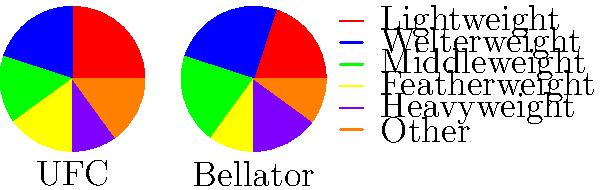As an MMA enthusiast with screenwriting experience, analyze the pie charts representing weight class distributions in UFC and Bellator. Which weight class shows the most significant difference in representation between the two organizations, and how might this impact storylines in an MMA-themed screenplay? To answer this question, we need to compare the weight class distributions between UFC and Bellator:

1. Lightweight:
   UFC: 25%, Bellator: 20%
   Difference: 5%

2. Welterweight:
   UFC: 20%, Bellator: 25%
   Difference: 5%

3. Middleweight:
   UFC: 15%, Bellator: 20%
   Difference: 5%

4. Featherweight:
   UFC: 15%, Bellator: 10%
   Difference: 5%

5. Heavyweight:
   UFC: 10%, Bellator: 15%
   Difference: 5%

6. Other:
   UFC: 15%, Bellator: 10%
   Difference: 5%

The most significant difference is a tie between all weight classes, each showing a 5% difference between UFC and Bellator.

For screenplay impact, consider:

1. Welterweight has the highest representation in Bellator (25%) vs. UFC (20%). This could lead to storylines about welterweight fighters choosing Bellator for more opportunities.

2. Lightweight has the highest representation in UFC (25%) vs. Bellator (20%). This might create narratives about lightweight fighters aspiring to compete in the UFC.

3. The "Other" category shows more diversity in UFC (15%) vs. Bellator (10%), potentially leading to stories about niche weight classes or catchweight bouts.

4. Heavyweight has a higher representation in Bellator (15%) vs. UFC (10%), which could inspire stories about up-and-coming heavyweights choosing Bellator as a stepping stone.

These differences can be used to create compelling character arcs, rivalries between promotions, and explore themes of opportunity and competition in the MMA world.
Answer: All weight classes show a 5% difference; storylines could focus on fighters' promotion choices based on weight class opportunities. 